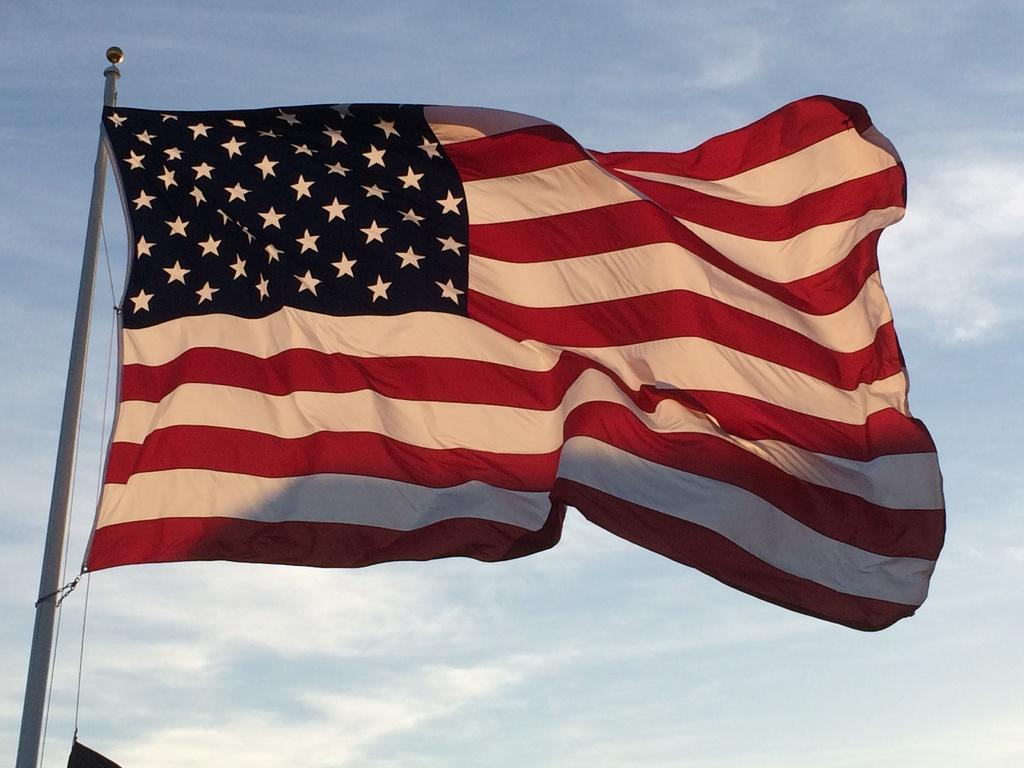What flag is visible in the image? The American flag is present in the image. Where is the flag post located in the image? The flag post is on the left side of the image. What can be seen in the background of the image? The sky is visible in the background of the image. What type of celery is being used to decorate the flag in the image? There is no celery present in the image, and the flag is not being decorated with any vegetables. 